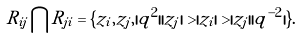Convert formula to latex. <formula><loc_0><loc_0><loc_500><loc_500>R _ { i j } \bigcap R _ { j i } = \{ z _ { i } , z _ { j } , | q ^ { 2 } | | z _ { j } | > | z _ { i } | > | z _ { j } | | q ^ { - 2 } | \} .</formula> 